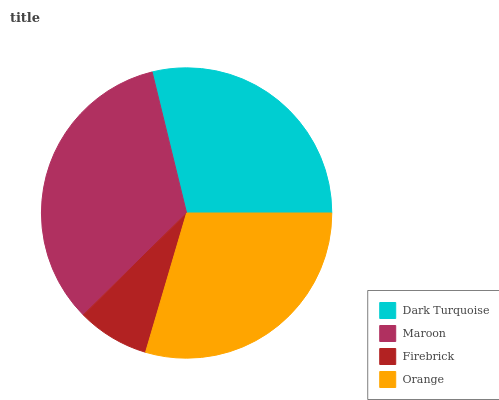Is Firebrick the minimum?
Answer yes or no. Yes. Is Maroon the maximum?
Answer yes or no. Yes. Is Maroon the minimum?
Answer yes or no. No. Is Firebrick the maximum?
Answer yes or no. No. Is Maroon greater than Firebrick?
Answer yes or no. Yes. Is Firebrick less than Maroon?
Answer yes or no. Yes. Is Firebrick greater than Maroon?
Answer yes or no. No. Is Maroon less than Firebrick?
Answer yes or no. No. Is Orange the high median?
Answer yes or no. Yes. Is Dark Turquoise the low median?
Answer yes or no. Yes. Is Maroon the high median?
Answer yes or no. No. Is Maroon the low median?
Answer yes or no. No. 